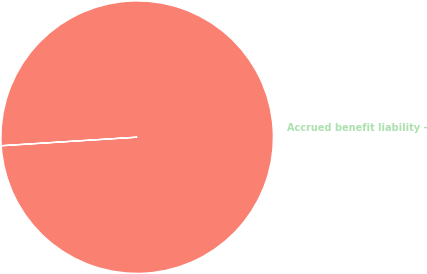Convert chart. <chart><loc_0><loc_0><loc_500><loc_500><pie_chart><fcel>Accrued benefit liability -<nl><fcel>100.0%<nl></chart> 